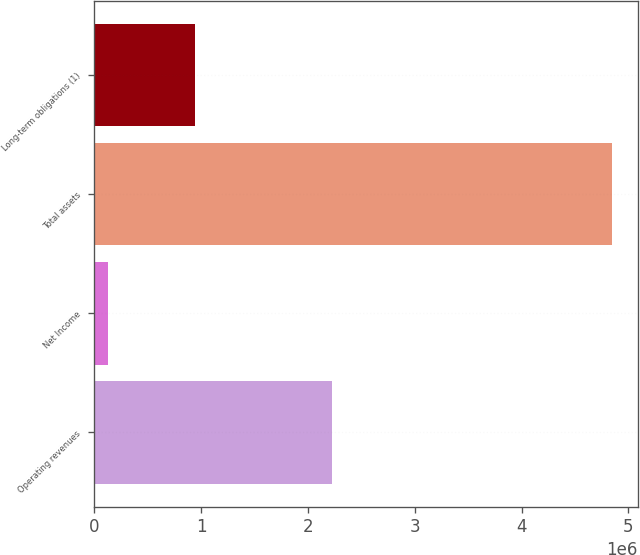Convert chart. <chart><loc_0><loc_0><loc_500><loc_500><bar_chart><fcel>Operating revenues<fcel>Net Income<fcel>Total assets<fcel>Long-term obligations (1)<nl><fcel>2.22699e+06<fcel>127495<fcel>4.8456e+06<fcel>939598<nl></chart> 